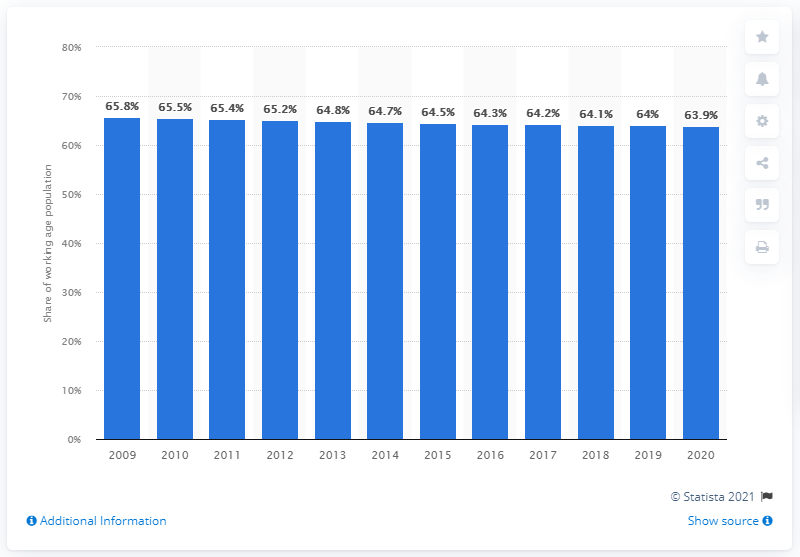Specify some key components in this picture. In 2020, the working age population of Italy was 63.9 million people. 